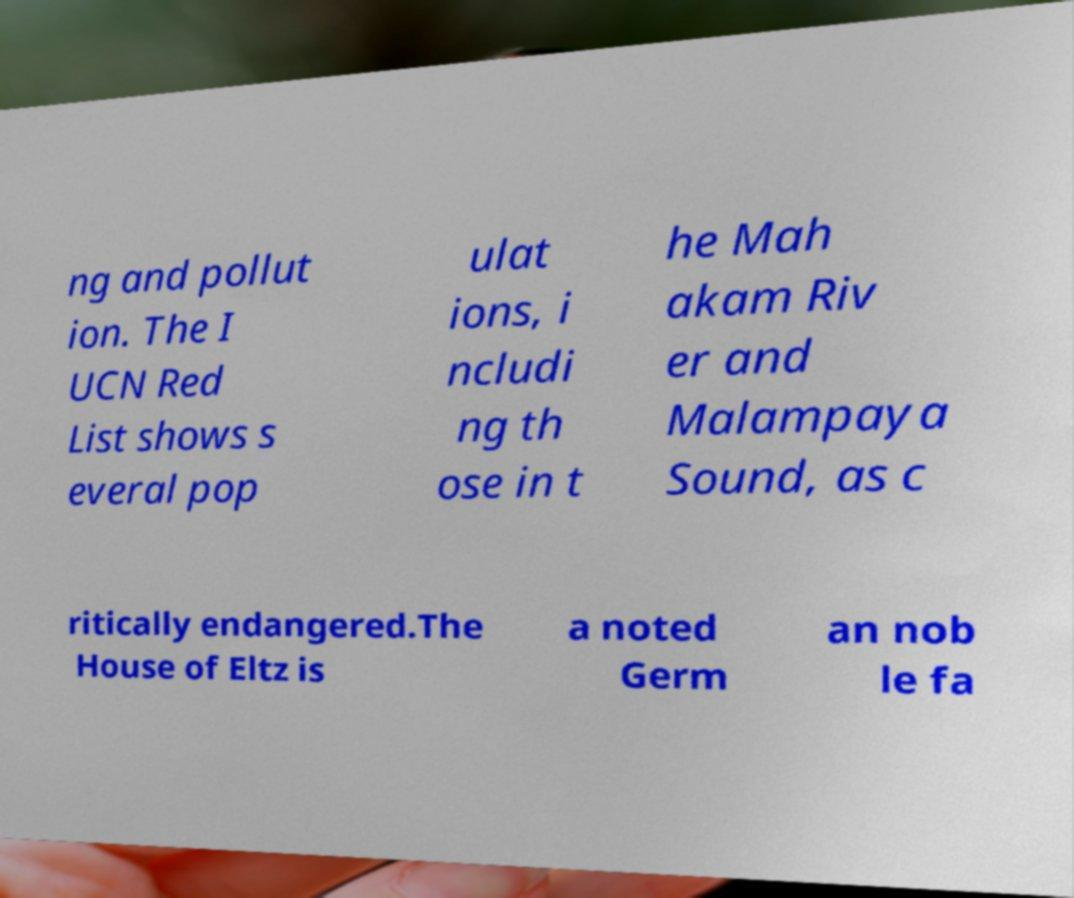For documentation purposes, I need the text within this image transcribed. Could you provide that? ng and pollut ion. The I UCN Red List shows s everal pop ulat ions, i ncludi ng th ose in t he Mah akam Riv er and Malampaya Sound, as c ritically endangered.The House of Eltz is a noted Germ an nob le fa 